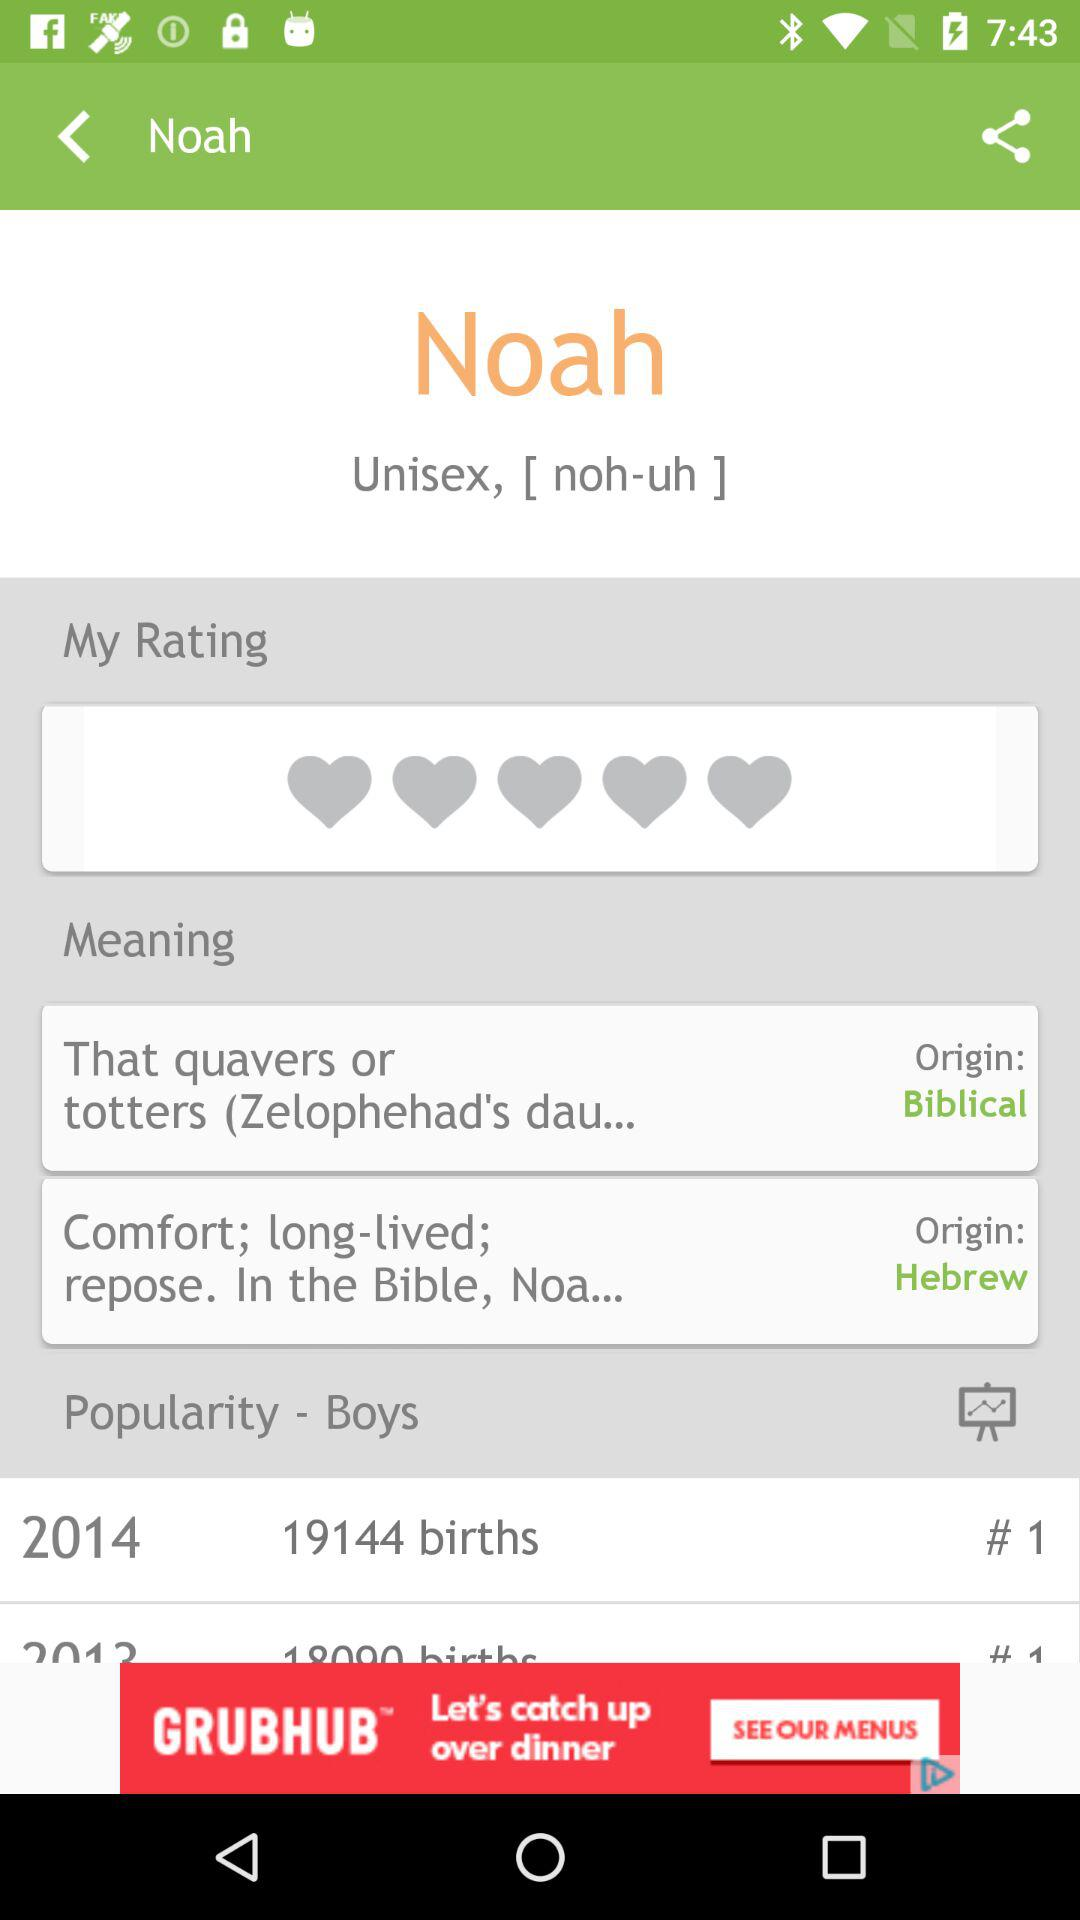What gender has popularity? The gender is "Boys". 